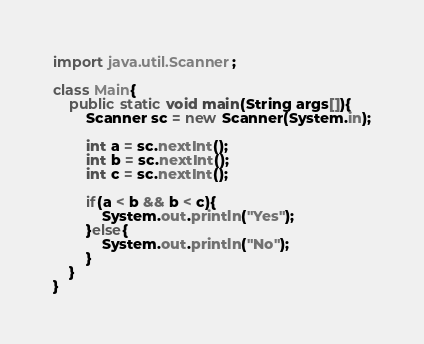Convert code to text. <code><loc_0><loc_0><loc_500><loc_500><_Java_>import java.util.Scanner;

class Main{
    public static void main(String args[]){
        Scanner sc = new Scanner(System.in);

        int a = sc.nextInt();
        int b = sc.nextInt();
        int c = sc.nextInt();

        if(a < b && b < c){
            System.out.println("Yes");
        }else{
            System.out.println("No");
        }
    }
}
</code> 